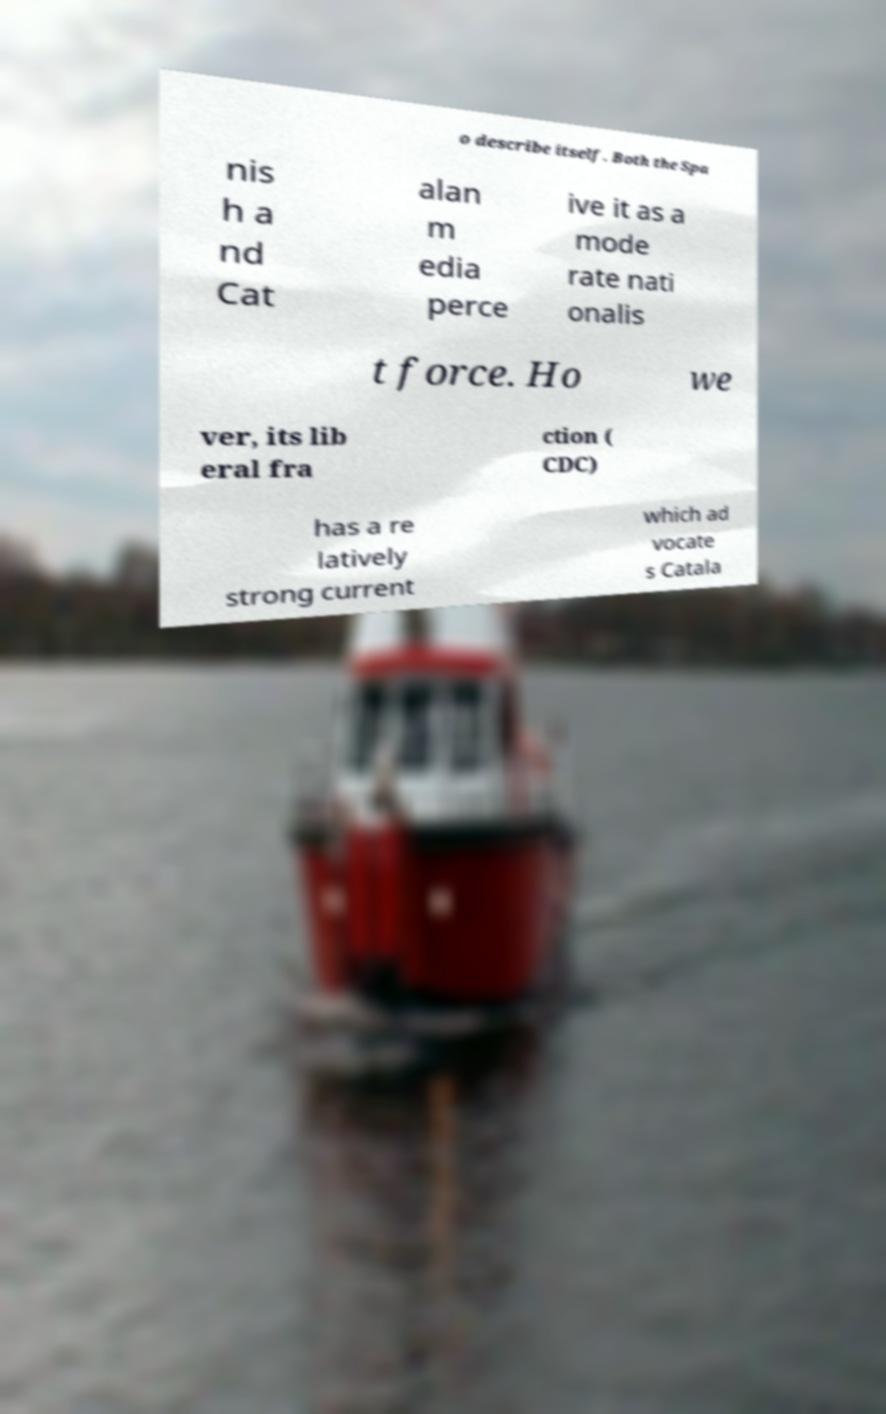For documentation purposes, I need the text within this image transcribed. Could you provide that? o describe itself. Both the Spa nis h a nd Cat alan m edia perce ive it as a mode rate nati onalis t force. Ho we ver, its lib eral fra ction ( CDC) has a re latively strong current which ad vocate s Catala 